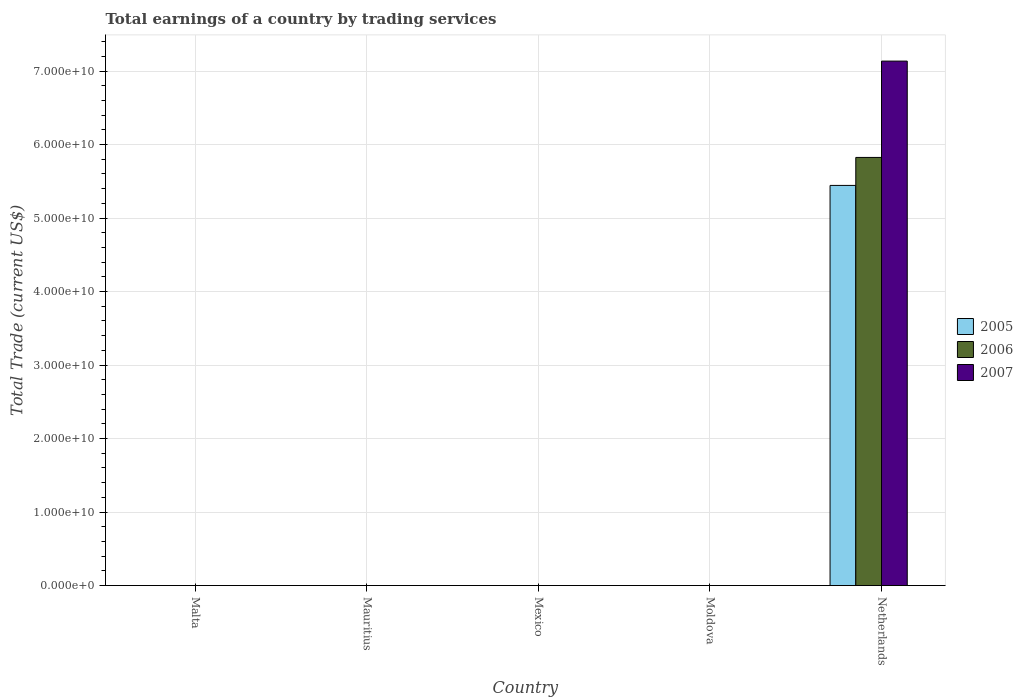Are the number of bars on each tick of the X-axis equal?
Make the answer very short. No. How many bars are there on the 5th tick from the left?
Provide a succinct answer. 3. What is the label of the 1st group of bars from the left?
Your answer should be compact. Malta. Across all countries, what is the maximum total earnings in 2006?
Give a very brief answer. 5.82e+1. What is the total total earnings in 2006 in the graph?
Ensure brevity in your answer.  5.82e+1. What is the difference between the total earnings in 2006 in Mauritius and the total earnings in 2005 in Malta?
Offer a terse response. 0. What is the average total earnings in 2006 per country?
Provide a short and direct response. 1.16e+1. What is the difference between the total earnings of/in 2007 and total earnings of/in 2006 in Netherlands?
Make the answer very short. 1.31e+1. In how many countries, is the total earnings in 2005 greater than 46000000000 US$?
Offer a terse response. 1. What is the difference between the highest and the lowest total earnings in 2006?
Provide a succinct answer. 5.82e+1. In how many countries, is the total earnings in 2006 greater than the average total earnings in 2006 taken over all countries?
Offer a very short reply. 1. Are all the bars in the graph horizontal?
Keep it short and to the point. No. What is the difference between two consecutive major ticks on the Y-axis?
Your response must be concise. 1.00e+1. Does the graph contain any zero values?
Ensure brevity in your answer.  Yes. Where does the legend appear in the graph?
Give a very brief answer. Center right. What is the title of the graph?
Your answer should be very brief. Total earnings of a country by trading services. Does "2010" appear as one of the legend labels in the graph?
Ensure brevity in your answer.  No. What is the label or title of the Y-axis?
Your answer should be very brief. Total Trade (current US$). What is the Total Trade (current US$) of 2005 in Malta?
Your answer should be compact. 0. What is the Total Trade (current US$) in 2006 in Malta?
Offer a very short reply. 0. What is the Total Trade (current US$) of 2007 in Malta?
Provide a succinct answer. 0. What is the Total Trade (current US$) in 2007 in Mauritius?
Keep it short and to the point. 0. What is the Total Trade (current US$) in 2005 in Mexico?
Give a very brief answer. 0. What is the Total Trade (current US$) of 2006 in Mexico?
Provide a succinct answer. 0. What is the Total Trade (current US$) in 2007 in Mexico?
Offer a very short reply. 0. What is the Total Trade (current US$) in 2006 in Moldova?
Provide a short and direct response. 0. What is the Total Trade (current US$) of 2007 in Moldova?
Make the answer very short. 0. What is the Total Trade (current US$) of 2005 in Netherlands?
Keep it short and to the point. 5.44e+1. What is the Total Trade (current US$) of 2006 in Netherlands?
Make the answer very short. 5.82e+1. What is the Total Trade (current US$) in 2007 in Netherlands?
Provide a short and direct response. 7.14e+1. Across all countries, what is the maximum Total Trade (current US$) in 2005?
Provide a succinct answer. 5.44e+1. Across all countries, what is the maximum Total Trade (current US$) of 2006?
Your answer should be very brief. 5.82e+1. Across all countries, what is the maximum Total Trade (current US$) in 2007?
Your answer should be compact. 7.14e+1. Across all countries, what is the minimum Total Trade (current US$) of 2005?
Your answer should be compact. 0. Across all countries, what is the minimum Total Trade (current US$) of 2006?
Your answer should be very brief. 0. Across all countries, what is the minimum Total Trade (current US$) of 2007?
Ensure brevity in your answer.  0. What is the total Total Trade (current US$) of 2005 in the graph?
Your answer should be very brief. 5.44e+1. What is the total Total Trade (current US$) in 2006 in the graph?
Give a very brief answer. 5.82e+1. What is the total Total Trade (current US$) of 2007 in the graph?
Your answer should be compact. 7.14e+1. What is the average Total Trade (current US$) of 2005 per country?
Ensure brevity in your answer.  1.09e+1. What is the average Total Trade (current US$) in 2006 per country?
Ensure brevity in your answer.  1.16e+1. What is the average Total Trade (current US$) in 2007 per country?
Offer a terse response. 1.43e+1. What is the difference between the Total Trade (current US$) in 2005 and Total Trade (current US$) in 2006 in Netherlands?
Make the answer very short. -3.81e+09. What is the difference between the Total Trade (current US$) in 2005 and Total Trade (current US$) in 2007 in Netherlands?
Give a very brief answer. -1.69e+1. What is the difference between the Total Trade (current US$) of 2006 and Total Trade (current US$) of 2007 in Netherlands?
Ensure brevity in your answer.  -1.31e+1. What is the difference between the highest and the lowest Total Trade (current US$) in 2005?
Ensure brevity in your answer.  5.44e+1. What is the difference between the highest and the lowest Total Trade (current US$) in 2006?
Offer a terse response. 5.82e+1. What is the difference between the highest and the lowest Total Trade (current US$) in 2007?
Your answer should be compact. 7.14e+1. 